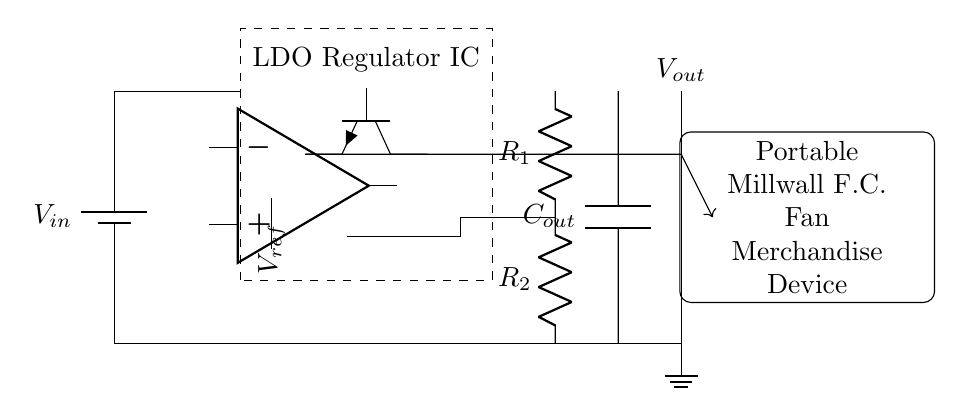What is the input voltage? The input voltage is represented by the label V_{in} at the top of the battery symbol.
Answer: V_{in} What is the purpose of the LDO regulator IC? The LDO regulator IC is used to maintain a stable output voltage (V_{out}) while allowing a low voltage drop from the input (V_{in}).
Answer: Stability What type of transistors are used in this circuit? An NPN transistor is indicated by the symbol shown, and it's utilized for controlling the output voltage.
Answer: NPN What are the two feedback resistors labeled? The two feedback resistors in the circuit are labeled R1 and R2, which help set the output voltage based on the feedback loop.
Answer: R1, R2 How many capacitors are present in the circuit? There is one capacitor labeled C_{out} connected at the output, helping to filter voltage variations.
Answer: One What does the legend "V_{ref}" indicate? V_{ref} represents a voltage reference that is critical for the function of the error amplifier and stability of the output voltage.
Answer: Voltage reference What function do the resistors R1 and R2 serve in this circuit? Resistors R1 and R2 form a voltage divider that sets the level of feedback to the error amplifier to regulate the output voltage.
Answer: Feedback regulation 